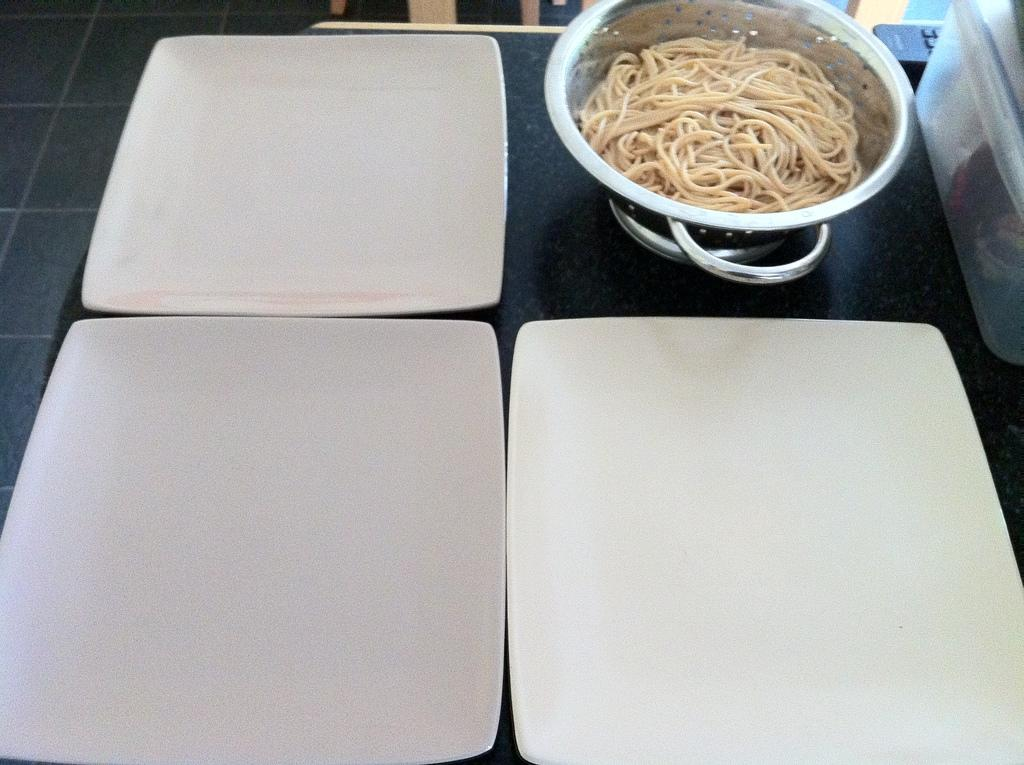What is in the bowl that is visible in the image? There is a bowl with noodles in it. How many plates are visible in the image? There are three plates in the image. What other object can be seen in the image besides the plates and the bowl of noodles? There is a box and a remote in the image. Where are all these objects placed? All of these objects are placed on a platform. Can you describe the background of the image? There are objects visible in the background of the image. What songs are being played by the engine in the background of the image? There is no engine or songs present in the image; it features a bowl of noodles, plates, a box, a remote, and other objects on a platform. Are there any ants visible in the image? There are no ants present in the image. 